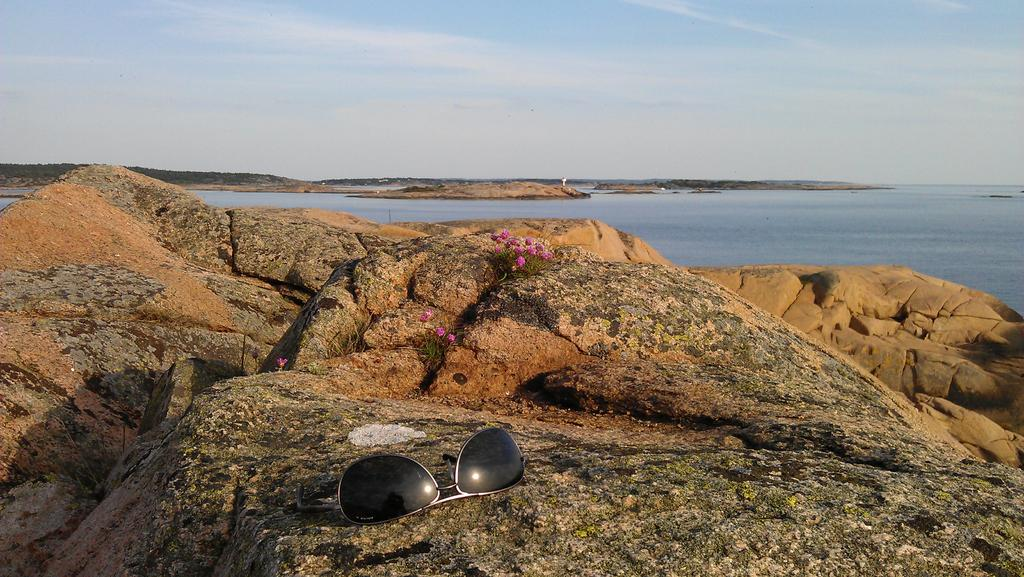What is placed on the rock in the image? There are goggles placed on a rock in the image. What type of vegetation can be seen in the image? There are flowers visible in the image. What is the primary element that is flowing in the image? There is water flowing in the image. What type of sign can be seen warning people about their fear in the image? There is no sign present in the image, and the image does not depict any fear-related warnings. What type of meal is being prepared in the image? There is no meal preparation visible in the image. 